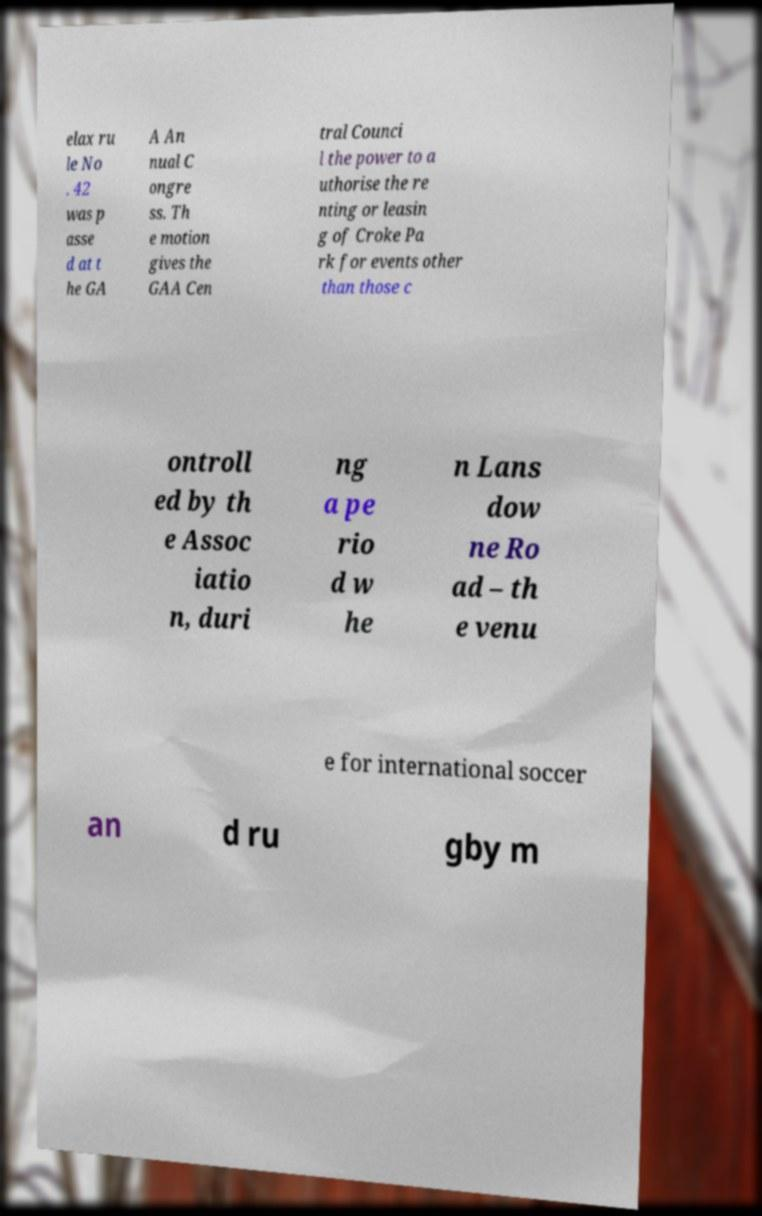What messages or text are displayed in this image? I need them in a readable, typed format. elax ru le No . 42 was p asse d at t he GA A An nual C ongre ss. Th e motion gives the GAA Cen tral Counci l the power to a uthorise the re nting or leasin g of Croke Pa rk for events other than those c ontroll ed by th e Assoc iatio n, duri ng a pe rio d w he n Lans dow ne Ro ad – th e venu e for international soccer an d ru gby m 